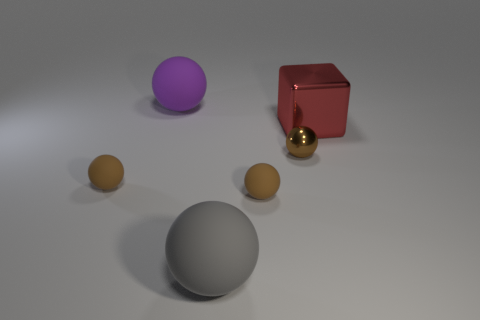How many brown balls must be subtracted to get 1 brown balls? 2 Subtract all spheres. How many objects are left? 1 Subtract 4 spheres. How many spheres are left? 1 Subtract all cyan spheres. Subtract all red blocks. How many spheres are left? 5 Subtract all cyan cylinders. How many cyan blocks are left? 0 Subtract all matte spheres. Subtract all large red cubes. How many objects are left? 1 Add 6 rubber spheres. How many rubber spheres are left? 10 Add 4 tiny yellow matte things. How many tiny yellow matte things exist? 4 Add 4 large green matte cylinders. How many objects exist? 10 Subtract all purple balls. How many balls are left? 4 